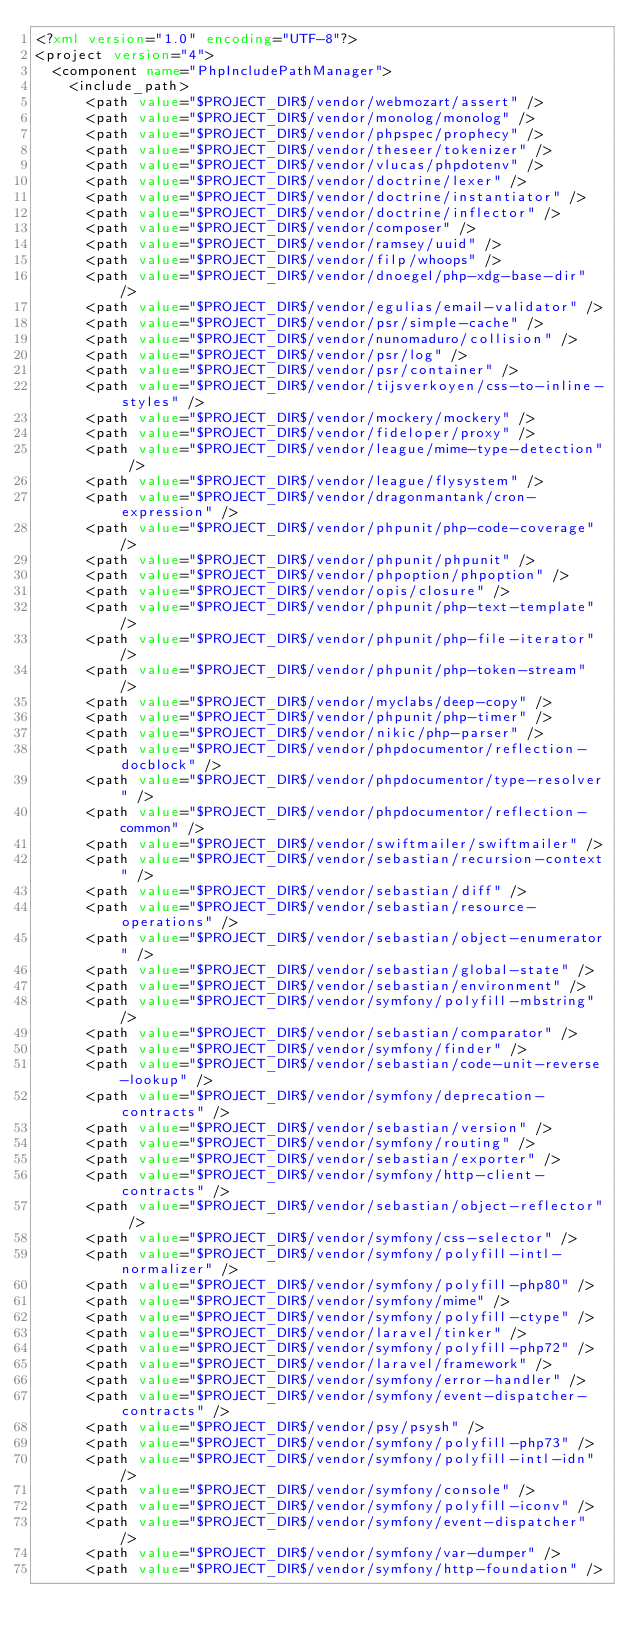Convert code to text. <code><loc_0><loc_0><loc_500><loc_500><_XML_><?xml version="1.0" encoding="UTF-8"?>
<project version="4">
  <component name="PhpIncludePathManager">
    <include_path>
      <path value="$PROJECT_DIR$/vendor/webmozart/assert" />
      <path value="$PROJECT_DIR$/vendor/monolog/monolog" />
      <path value="$PROJECT_DIR$/vendor/phpspec/prophecy" />
      <path value="$PROJECT_DIR$/vendor/theseer/tokenizer" />
      <path value="$PROJECT_DIR$/vendor/vlucas/phpdotenv" />
      <path value="$PROJECT_DIR$/vendor/doctrine/lexer" />
      <path value="$PROJECT_DIR$/vendor/doctrine/instantiator" />
      <path value="$PROJECT_DIR$/vendor/doctrine/inflector" />
      <path value="$PROJECT_DIR$/vendor/composer" />
      <path value="$PROJECT_DIR$/vendor/ramsey/uuid" />
      <path value="$PROJECT_DIR$/vendor/filp/whoops" />
      <path value="$PROJECT_DIR$/vendor/dnoegel/php-xdg-base-dir" />
      <path value="$PROJECT_DIR$/vendor/egulias/email-validator" />
      <path value="$PROJECT_DIR$/vendor/psr/simple-cache" />
      <path value="$PROJECT_DIR$/vendor/nunomaduro/collision" />
      <path value="$PROJECT_DIR$/vendor/psr/log" />
      <path value="$PROJECT_DIR$/vendor/psr/container" />
      <path value="$PROJECT_DIR$/vendor/tijsverkoyen/css-to-inline-styles" />
      <path value="$PROJECT_DIR$/vendor/mockery/mockery" />
      <path value="$PROJECT_DIR$/vendor/fideloper/proxy" />
      <path value="$PROJECT_DIR$/vendor/league/mime-type-detection" />
      <path value="$PROJECT_DIR$/vendor/league/flysystem" />
      <path value="$PROJECT_DIR$/vendor/dragonmantank/cron-expression" />
      <path value="$PROJECT_DIR$/vendor/phpunit/php-code-coverage" />
      <path value="$PROJECT_DIR$/vendor/phpunit/phpunit" />
      <path value="$PROJECT_DIR$/vendor/phpoption/phpoption" />
      <path value="$PROJECT_DIR$/vendor/opis/closure" />
      <path value="$PROJECT_DIR$/vendor/phpunit/php-text-template" />
      <path value="$PROJECT_DIR$/vendor/phpunit/php-file-iterator" />
      <path value="$PROJECT_DIR$/vendor/phpunit/php-token-stream" />
      <path value="$PROJECT_DIR$/vendor/myclabs/deep-copy" />
      <path value="$PROJECT_DIR$/vendor/phpunit/php-timer" />
      <path value="$PROJECT_DIR$/vendor/nikic/php-parser" />
      <path value="$PROJECT_DIR$/vendor/phpdocumentor/reflection-docblock" />
      <path value="$PROJECT_DIR$/vendor/phpdocumentor/type-resolver" />
      <path value="$PROJECT_DIR$/vendor/phpdocumentor/reflection-common" />
      <path value="$PROJECT_DIR$/vendor/swiftmailer/swiftmailer" />
      <path value="$PROJECT_DIR$/vendor/sebastian/recursion-context" />
      <path value="$PROJECT_DIR$/vendor/sebastian/diff" />
      <path value="$PROJECT_DIR$/vendor/sebastian/resource-operations" />
      <path value="$PROJECT_DIR$/vendor/sebastian/object-enumerator" />
      <path value="$PROJECT_DIR$/vendor/sebastian/global-state" />
      <path value="$PROJECT_DIR$/vendor/sebastian/environment" />
      <path value="$PROJECT_DIR$/vendor/symfony/polyfill-mbstring" />
      <path value="$PROJECT_DIR$/vendor/sebastian/comparator" />
      <path value="$PROJECT_DIR$/vendor/symfony/finder" />
      <path value="$PROJECT_DIR$/vendor/sebastian/code-unit-reverse-lookup" />
      <path value="$PROJECT_DIR$/vendor/symfony/deprecation-contracts" />
      <path value="$PROJECT_DIR$/vendor/sebastian/version" />
      <path value="$PROJECT_DIR$/vendor/symfony/routing" />
      <path value="$PROJECT_DIR$/vendor/sebastian/exporter" />
      <path value="$PROJECT_DIR$/vendor/symfony/http-client-contracts" />
      <path value="$PROJECT_DIR$/vendor/sebastian/object-reflector" />
      <path value="$PROJECT_DIR$/vendor/symfony/css-selector" />
      <path value="$PROJECT_DIR$/vendor/symfony/polyfill-intl-normalizer" />
      <path value="$PROJECT_DIR$/vendor/symfony/polyfill-php80" />
      <path value="$PROJECT_DIR$/vendor/symfony/mime" />
      <path value="$PROJECT_DIR$/vendor/symfony/polyfill-ctype" />
      <path value="$PROJECT_DIR$/vendor/laravel/tinker" />
      <path value="$PROJECT_DIR$/vendor/symfony/polyfill-php72" />
      <path value="$PROJECT_DIR$/vendor/laravel/framework" />
      <path value="$PROJECT_DIR$/vendor/symfony/error-handler" />
      <path value="$PROJECT_DIR$/vendor/symfony/event-dispatcher-contracts" />
      <path value="$PROJECT_DIR$/vendor/psy/psysh" />
      <path value="$PROJECT_DIR$/vendor/symfony/polyfill-php73" />
      <path value="$PROJECT_DIR$/vendor/symfony/polyfill-intl-idn" />
      <path value="$PROJECT_DIR$/vendor/symfony/console" />
      <path value="$PROJECT_DIR$/vendor/symfony/polyfill-iconv" />
      <path value="$PROJECT_DIR$/vendor/symfony/event-dispatcher" />
      <path value="$PROJECT_DIR$/vendor/symfony/var-dumper" />
      <path value="$PROJECT_DIR$/vendor/symfony/http-foundation" /></code> 